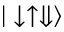Convert formula to latex. <formula><loc_0><loc_0><loc_500><loc_500>| \downarrow \uparrow \Downarrow \rangle</formula> 